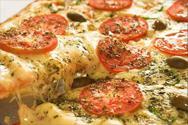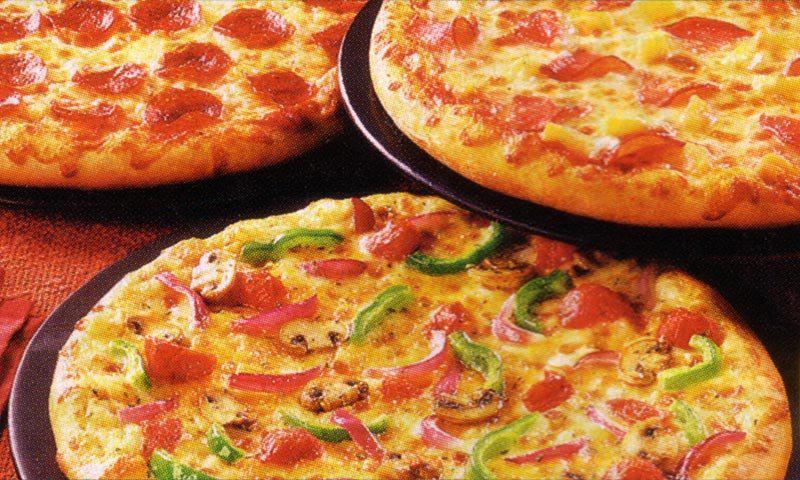The first image is the image on the left, the second image is the image on the right. Analyze the images presented: Is the assertion "At least one pizza has been sliced." valid? Answer yes or no. Yes. 